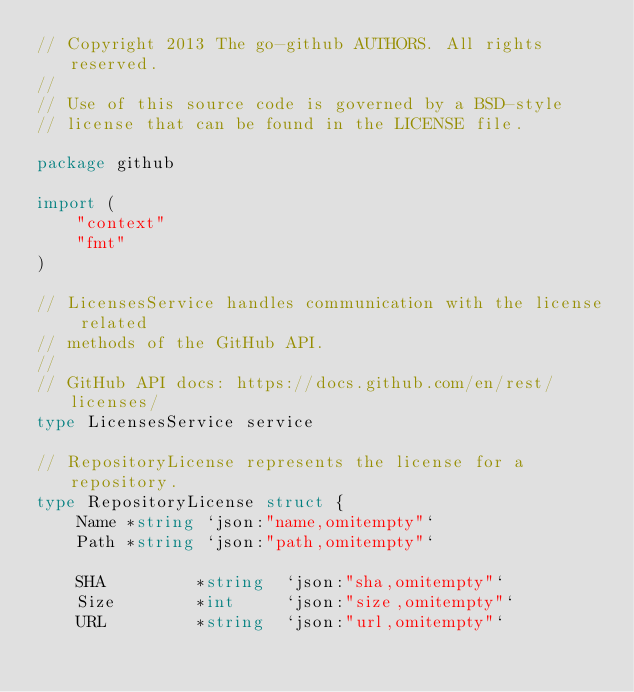<code> <loc_0><loc_0><loc_500><loc_500><_Go_>// Copyright 2013 The go-github AUTHORS. All rights reserved.
//
// Use of this source code is governed by a BSD-style
// license that can be found in the LICENSE file.

package github

import (
	"context"
	"fmt"
)

// LicensesService handles communication with the license related
// methods of the GitHub API.
//
// GitHub API docs: https://docs.github.com/en/rest/licenses/
type LicensesService service

// RepositoryLicense represents the license for a repository.
type RepositoryLicense struct {
	Name *string `json:"name,omitempty"`
	Path *string `json:"path,omitempty"`

	SHA         *string  `json:"sha,omitempty"`
	Size        *int     `json:"size,omitempty"`
	URL         *string  `json:"url,omitempty"`</code> 